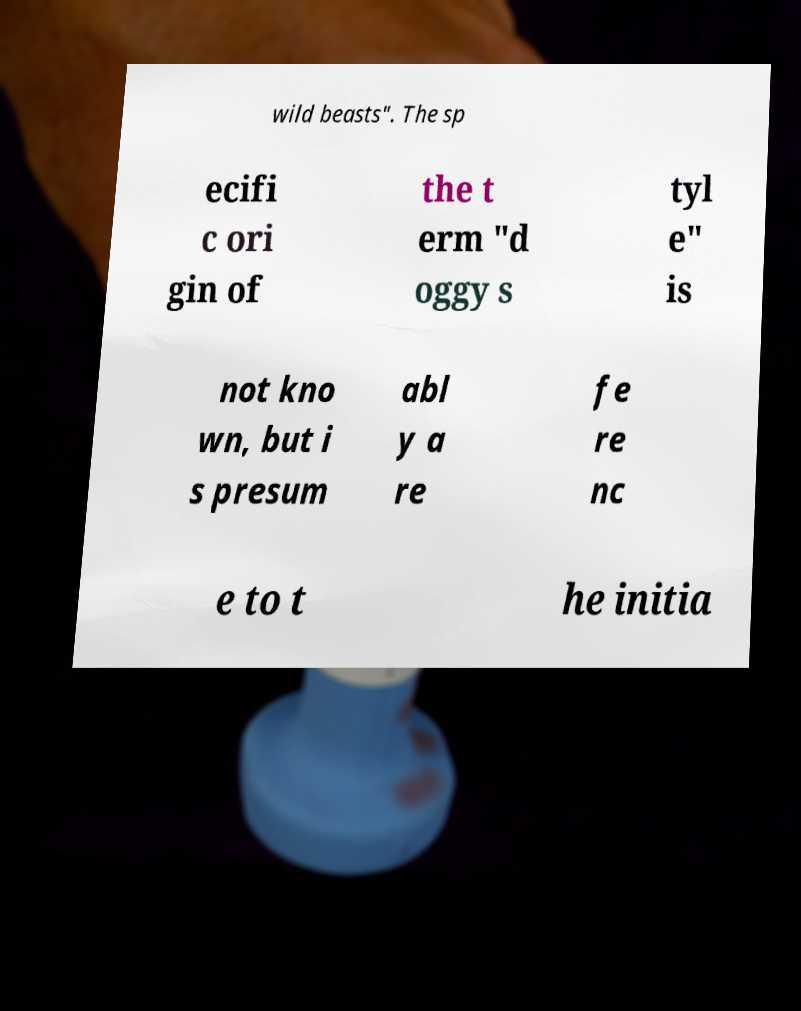Can you accurately transcribe the text from the provided image for me? wild beasts". The sp ecifi c ori gin of the t erm "d oggy s tyl e" is not kno wn, but i s presum abl y a re fe re nc e to t he initia 